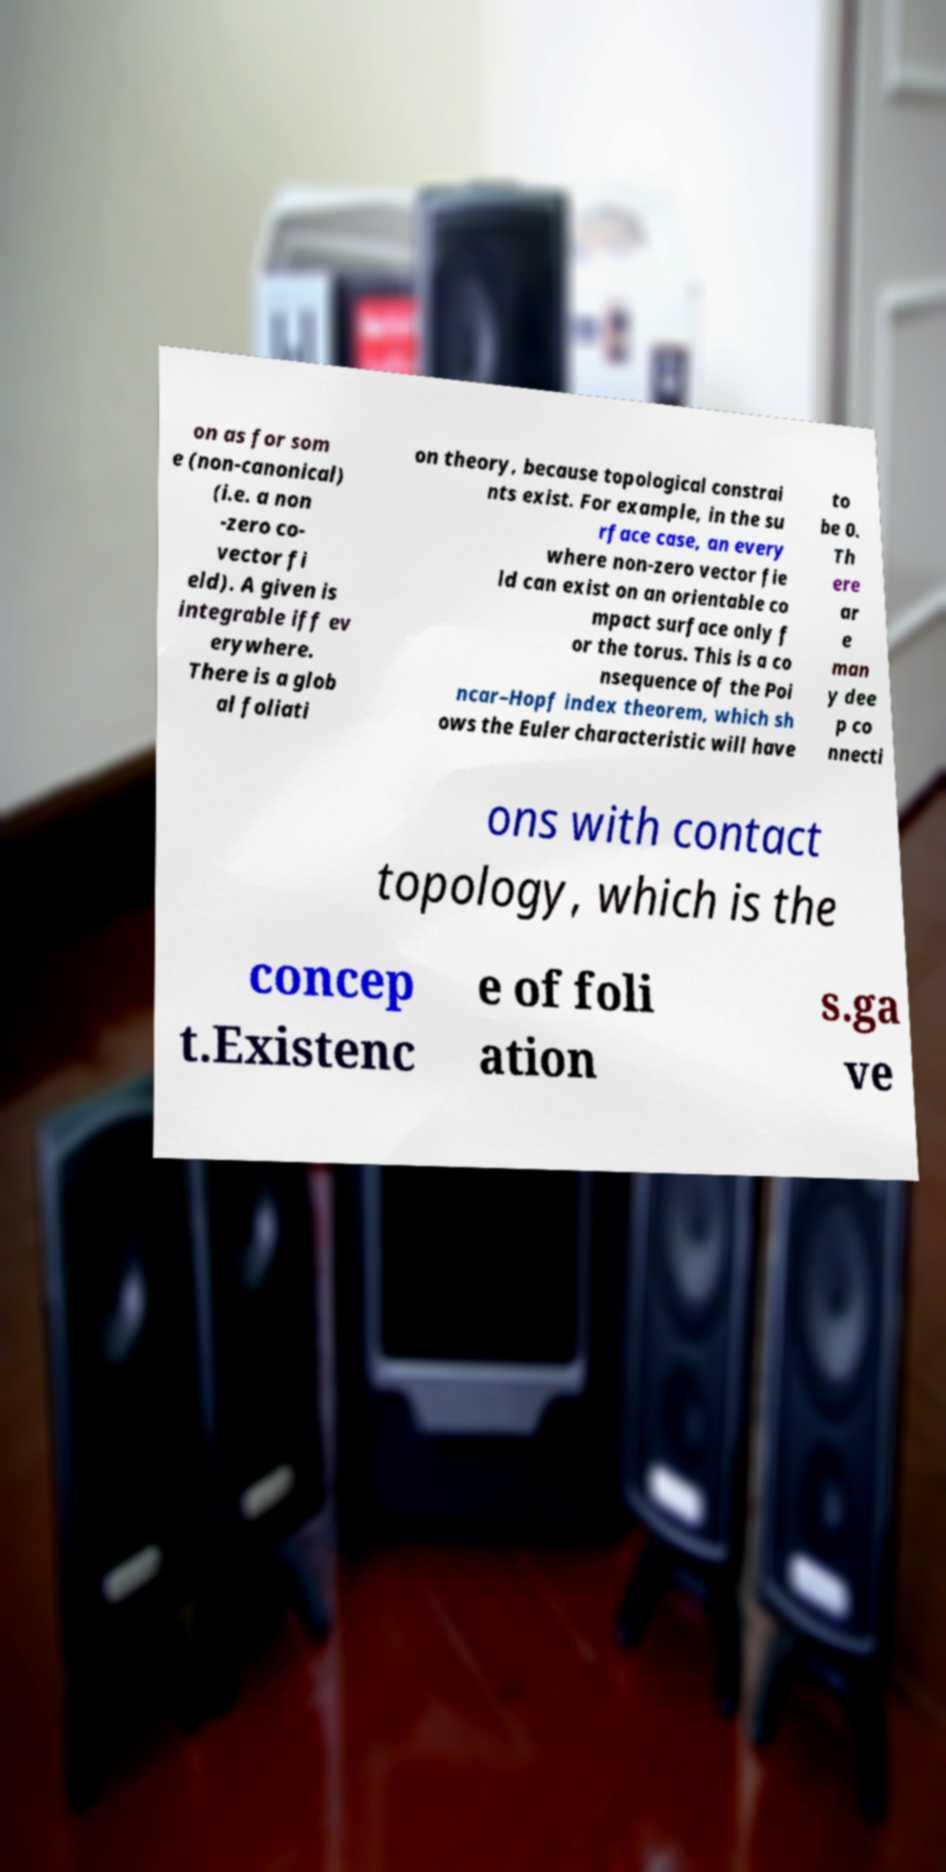What messages or text are displayed in this image? I need them in a readable, typed format. on as for som e (non-canonical) (i.e. a non -zero co- vector fi eld). A given is integrable iff ev erywhere. There is a glob al foliati on theory, because topological constrai nts exist. For example, in the su rface case, an every where non-zero vector fie ld can exist on an orientable co mpact surface only f or the torus. This is a co nsequence of the Poi ncar–Hopf index theorem, which sh ows the Euler characteristic will have to be 0. Th ere ar e man y dee p co nnecti ons with contact topology, which is the concep t.Existenc e of foli ation s.ga ve 